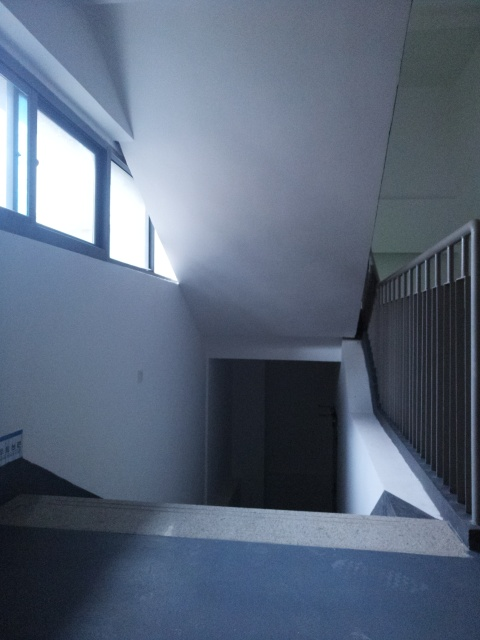What time of day does this image appear to be taken? The image seems to be taken during twilight or early evening, as suggested by the dim natural light coming from the windows and the absence of artificial lighting inside the space. 